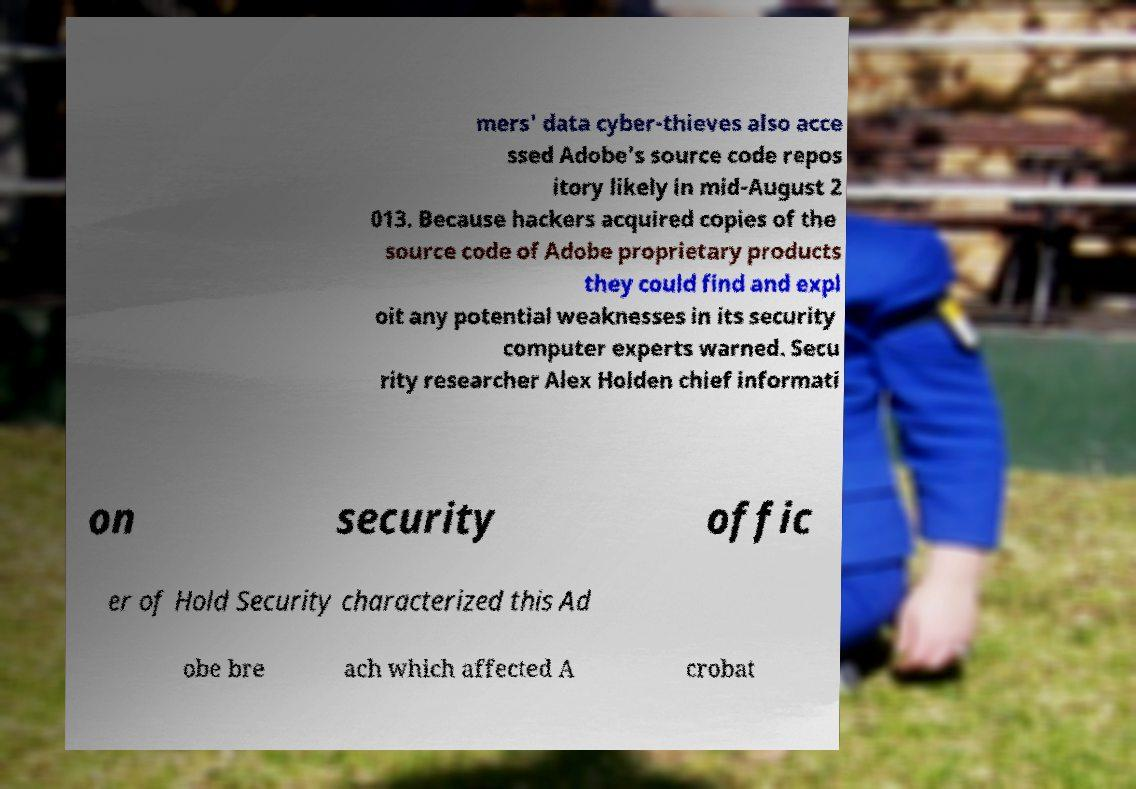Could you extract and type out the text from this image? mers' data cyber-thieves also acce ssed Adobe's source code repos itory likely in mid-August 2 013. Because hackers acquired copies of the source code of Adobe proprietary products they could find and expl oit any potential weaknesses in its security computer experts warned. Secu rity researcher Alex Holden chief informati on security offic er of Hold Security characterized this Ad obe bre ach which affected A crobat 